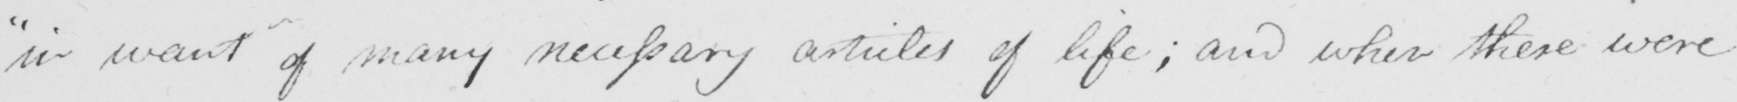What is written in this line of handwriting? in want of many necessary articles of life ; and when these were 